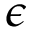<formula> <loc_0><loc_0><loc_500><loc_500>\epsilon</formula> 